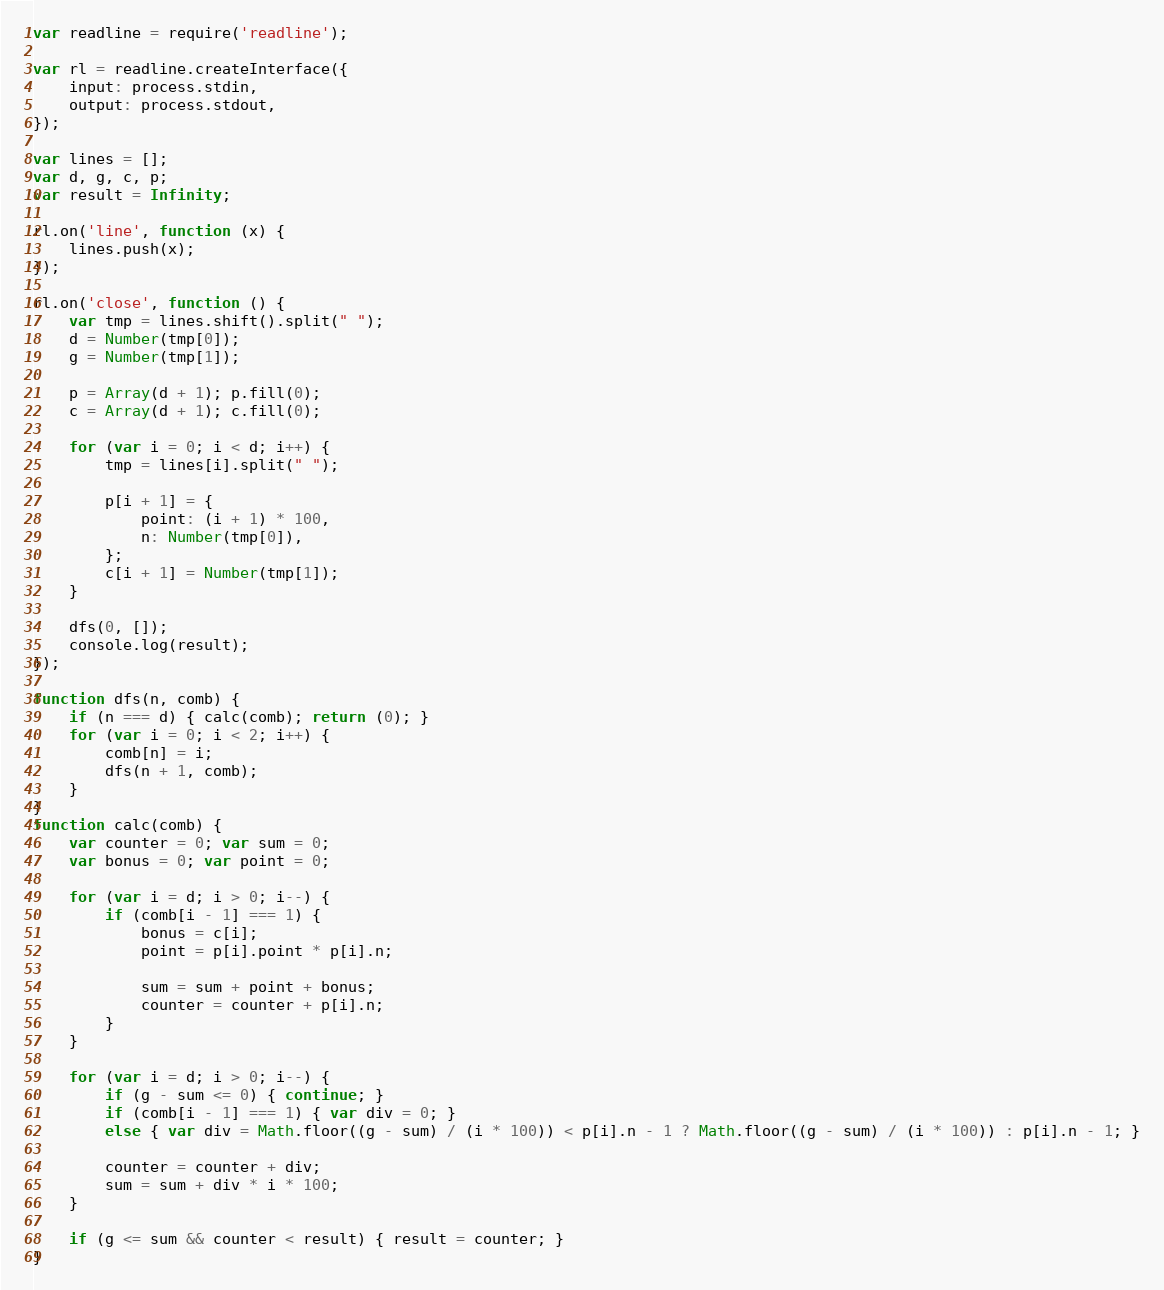Convert code to text. <code><loc_0><loc_0><loc_500><loc_500><_JavaScript_>var readline = require('readline');

var rl = readline.createInterface({
    input: process.stdin,
    output: process.stdout,
});

var lines = [];
var d, g, c, p;
var result = Infinity;

rl.on('line', function (x) {
    lines.push(x);
});

rl.on('close', function () {
    var tmp = lines.shift().split(" ");
    d = Number(tmp[0]);
    g = Number(tmp[1]);

    p = Array(d + 1); p.fill(0);
    c = Array(d + 1); c.fill(0);

    for (var i = 0; i < d; i++) {
        tmp = lines[i].split(" ");

        p[i + 1] = {
            point: (i + 1) * 100,
            n: Number(tmp[0]),
        };
        c[i + 1] = Number(tmp[1]);
    }

    dfs(0, []);
    console.log(result);
});

function dfs(n, comb) {
    if (n === d) { calc(comb); return (0); }
    for (var i = 0; i < 2; i++) {
        comb[n] = i;
        dfs(n + 1, comb);
    }
}
function calc(comb) {
    var counter = 0; var sum = 0;
    var bonus = 0; var point = 0;

    for (var i = d; i > 0; i--) {
        if (comb[i - 1] === 1) {
            bonus = c[i];
            point = p[i].point * p[i].n;

            sum = sum + point + bonus;
            counter = counter + p[i].n;
        }
    }

    for (var i = d; i > 0; i--) {
        if (g - sum <= 0) { continue; }
        if (comb[i - 1] === 1) { var div = 0; }
        else { var div = Math.floor((g - sum) / (i * 100)) < p[i].n - 1 ? Math.floor((g - sum) / (i * 100)) : p[i].n - 1; }

        counter = counter + div;
        sum = sum + div * i * 100;
    }

    if (g <= sum && counter < result) { result = counter; }
}</code> 